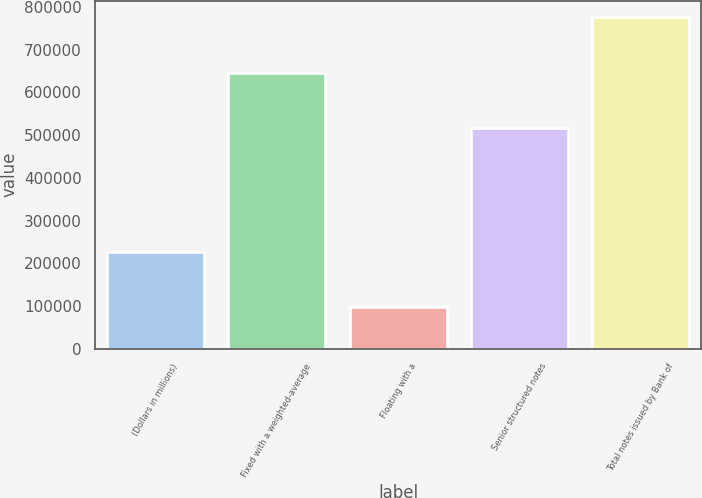Convert chart to OTSL. <chart><loc_0><loc_0><loc_500><loc_500><bar_chart><fcel>(Dollars in millions)<fcel>Fixed with a weighted-average<fcel>Floating with a<fcel>Senior structured notes<fcel>Total notes issued by Bank of<nl><fcel>226297<fcel>646258<fcel>97078.1<fcel>517039<fcel>775477<nl></chart> 